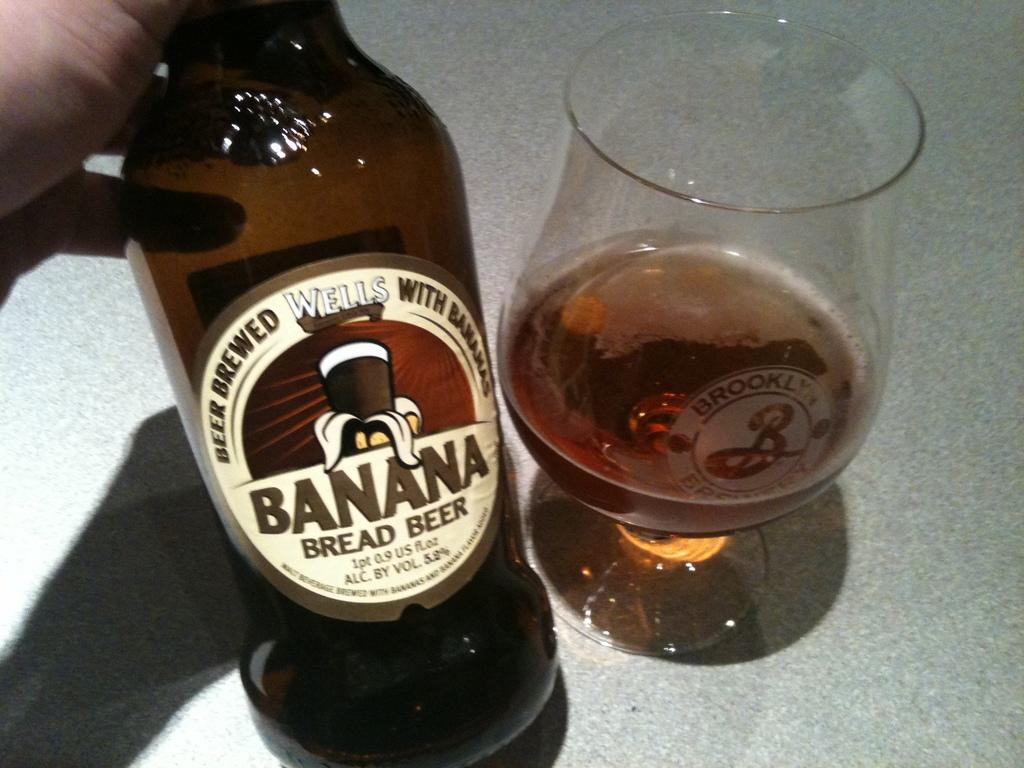What object can be seen in the image that contains a liquid? There is a bottle in the image. What is on the surface of the bottle? The bottle has oil on it. What type of container is filled with liquid in the image? There is a class filled with liquid in the image. What does the surface in the image resemble? The surface in the image looks like a floor. What type of creature is trying to get the attention of the person in the image? There is no creature present in the image, and therefore no such interaction can be observed. 